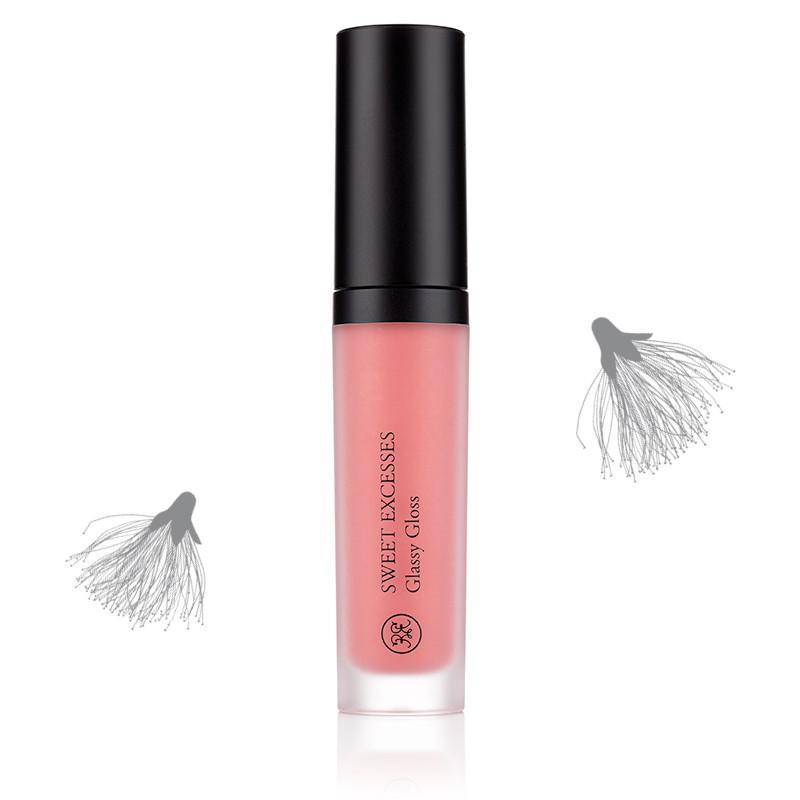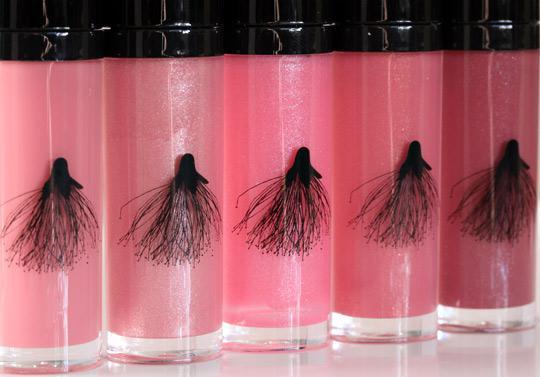The first image is the image on the left, the second image is the image on the right. Given the left and right images, does the statement "One image shows a lip makeup with its cover off." hold true? Answer yes or no. No. 